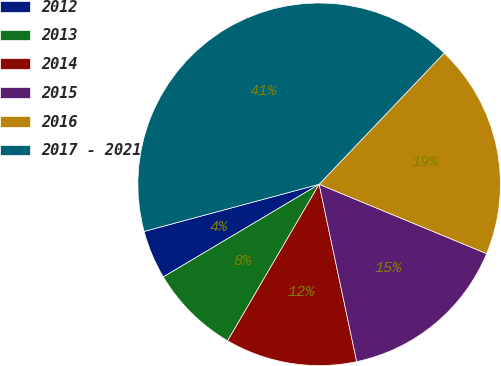Convert chart to OTSL. <chart><loc_0><loc_0><loc_500><loc_500><pie_chart><fcel>2012<fcel>2013<fcel>2014<fcel>2015<fcel>2016<fcel>2017 - 2021<nl><fcel>4.35%<fcel>8.04%<fcel>11.74%<fcel>15.43%<fcel>19.13%<fcel>41.3%<nl></chart> 